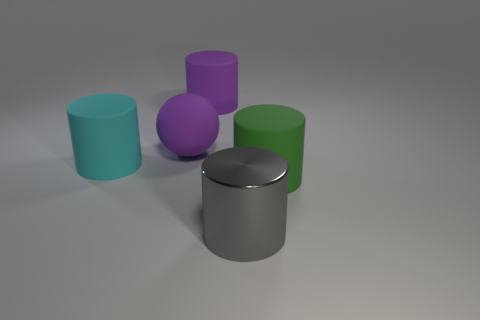Add 3 tiny red matte spheres. How many objects exist? 8 Subtract all cylinders. How many objects are left? 1 Add 1 green cylinders. How many green cylinders exist? 2 Subtract 1 green cylinders. How many objects are left? 4 Subtract all large purple cylinders. Subtract all big purple matte things. How many objects are left? 2 Add 4 purple cylinders. How many purple cylinders are left? 5 